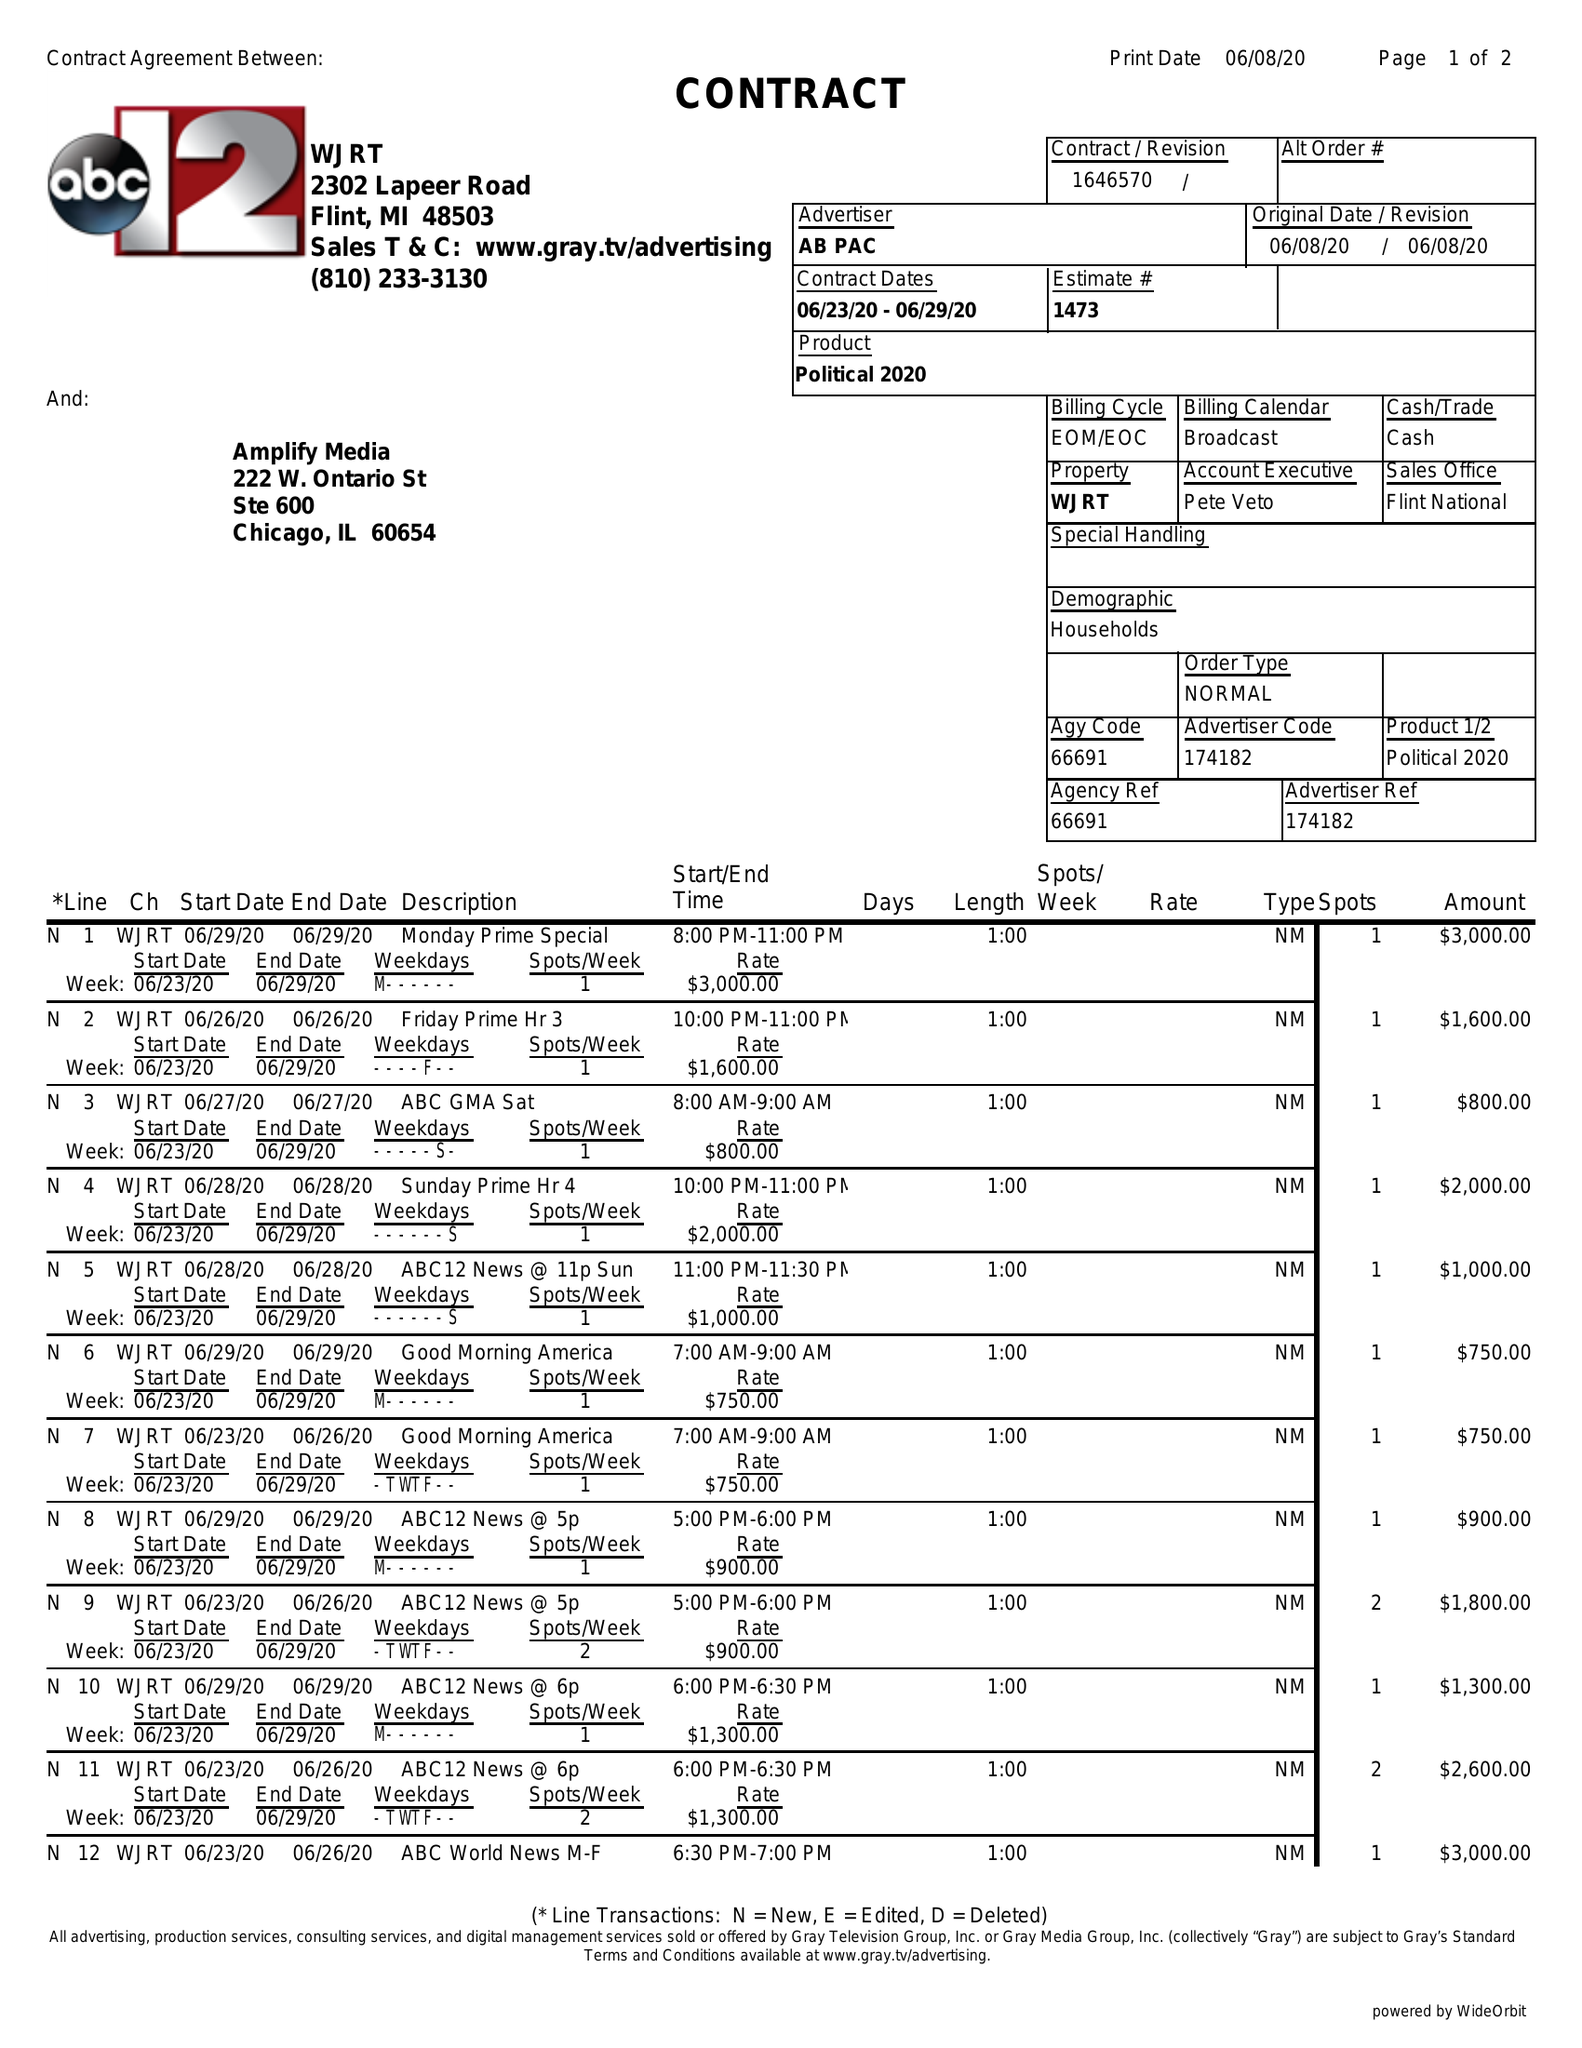What is the value for the flight_to?
Answer the question using a single word or phrase. 06/29/20 